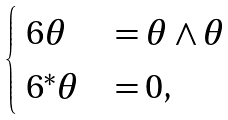<formula> <loc_0><loc_0><loc_500><loc_500>\begin{cases} \ 6 \theta & = \theta \wedge \theta \\ \ 6 ^ { * } \theta & = 0 , \end{cases}</formula> 